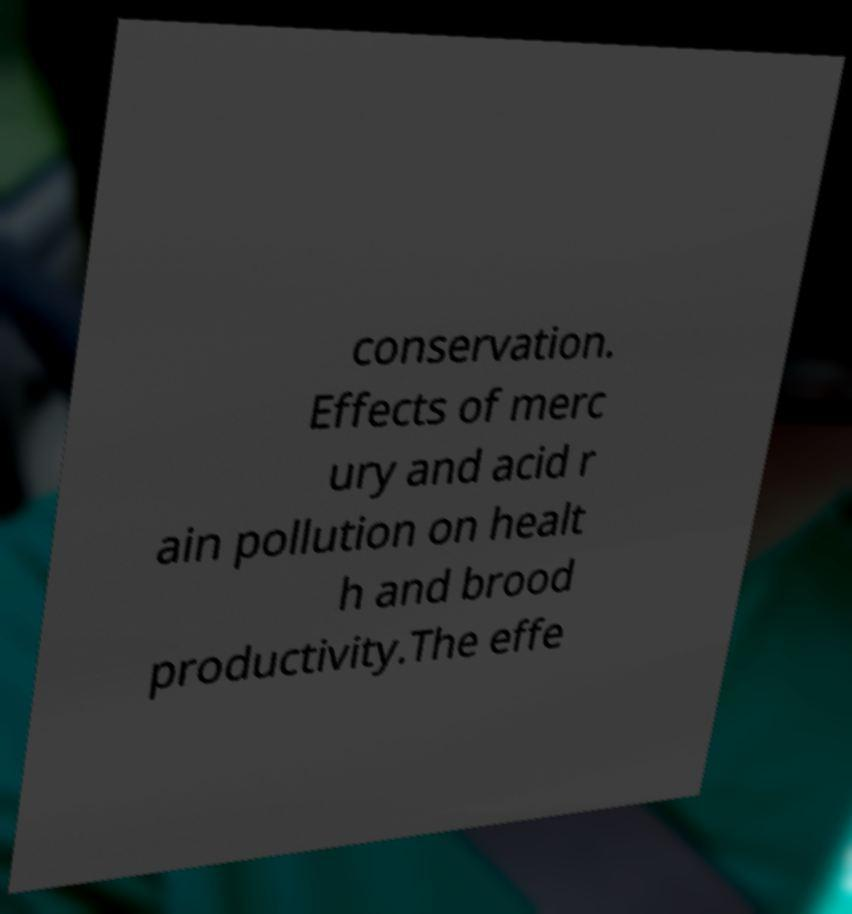Could you extract and type out the text from this image? conservation. Effects of merc ury and acid r ain pollution on healt h and brood productivity.The effe 